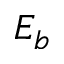Convert formula to latex. <formula><loc_0><loc_0><loc_500><loc_500>E _ { b }</formula> 